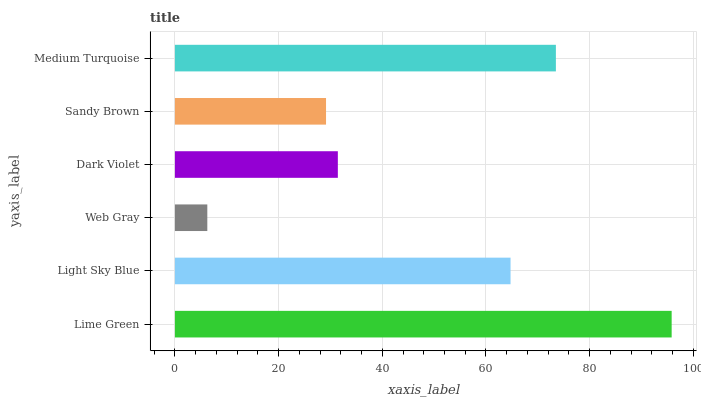Is Web Gray the minimum?
Answer yes or no. Yes. Is Lime Green the maximum?
Answer yes or no. Yes. Is Light Sky Blue the minimum?
Answer yes or no. No. Is Light Sky Blue the maximum?
Answer yes or no. No. Is Lime Green greater than Light Sky Blue?
Answer yes or no. Yes. Is Light Sky Blue less than Lime Green?
Answer yes or no. Yes. Is Light Sky Blue greater than Lime Green?
Answer yes or no. No. Is Lime Green less than Light Sky Blue?
Answer yes or no. No. Is Light Sky Blue the high median?
Answer yes or no. Yes. Is Dark Violet the low median?
Answer yes or no. Yes. Is Web Gray the high median?
Answer yes or no. No. Is Medium Turquoise the low median?
Answer yes or no. No. 